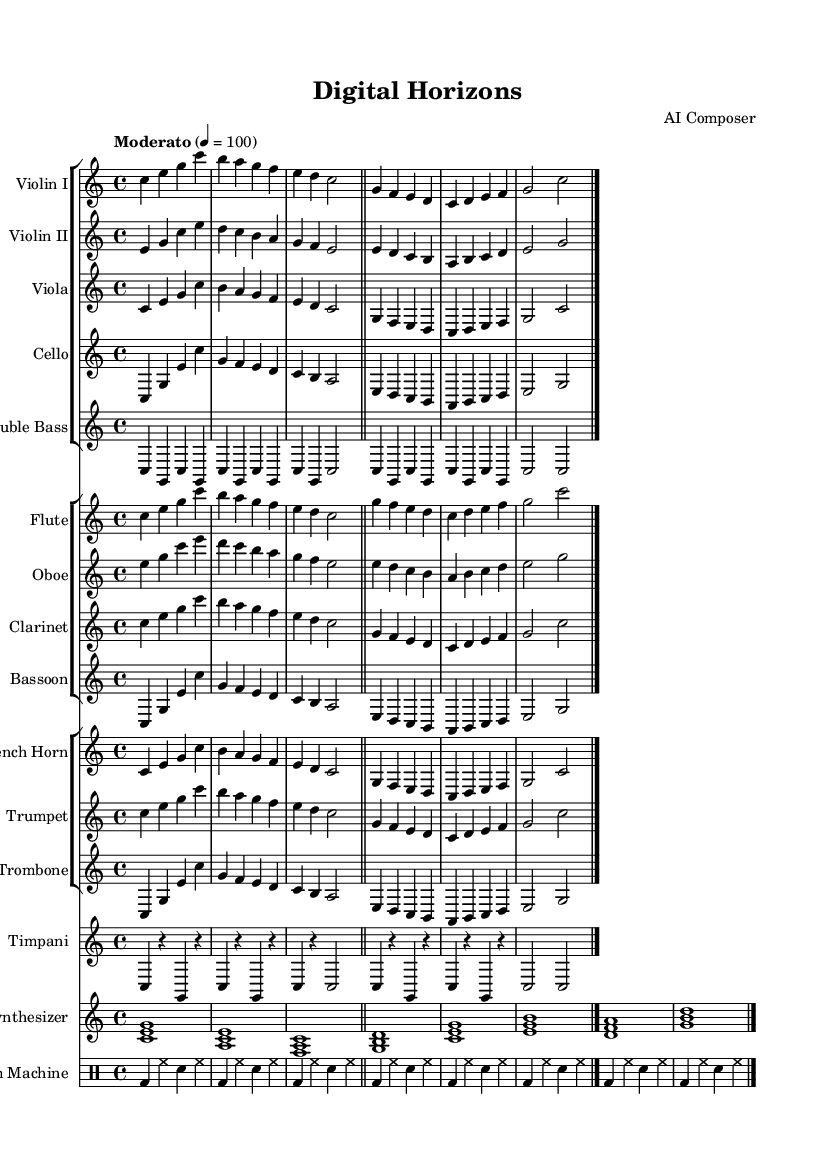What is the key signature of this music? The key signature is indicated at the beginning of the score and shows no sharps or flats, which means it is C major.
Answer: C major What is the time signature of this music? The time signature is indicated at the beginning of the score and shows 4 beats per measure, indicated by 4/4.
Answer: 4/4 What is the tempo marking for this symphony? The tempo is specified in the score as "Moderato," indicating a moderate speed, and the metronome marking is 4 equals 100 beats per minute.
Answer: Moderato How many instruments are there in this score? By counting each staff group and individual instrument parts listed in the score, there are a total of 13 distinct instruments presented.
Answer: 13 Which instruments play the synthesizer part? The synthesizer part is indicated in the piano staff labeled "Synthesizer," showing that it is performed by an electronic synthesizer instrument.
Answer: Synthesizer What type of percussion is used in this symphony? The score specifies a "Drum Machine," indicating the use of an electronic drum programming element typical of experimental compositions.
Answer: Drum Machine Which sections of the orchestra are represented in this score? The score includes string, woodwind, brass, and percussion sections, indicating a full range orchestration typical of a symphonic work.
Answer: Strings, Woodwinds, Brass, and Percussion 